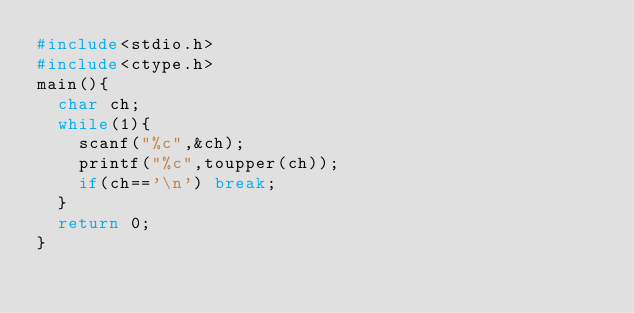Convert code to text. <code><loc_0><loc_0><loc_500><loc_500><_C_>#include<stdio.h>
#include<ctype.h>
main(){
  char ch;
  while(1){
    scanf("%c",&ch);
    printf("%c",toupper(ch));
    if(ch=='\n') break;
  }
  return 0;
}</code> 